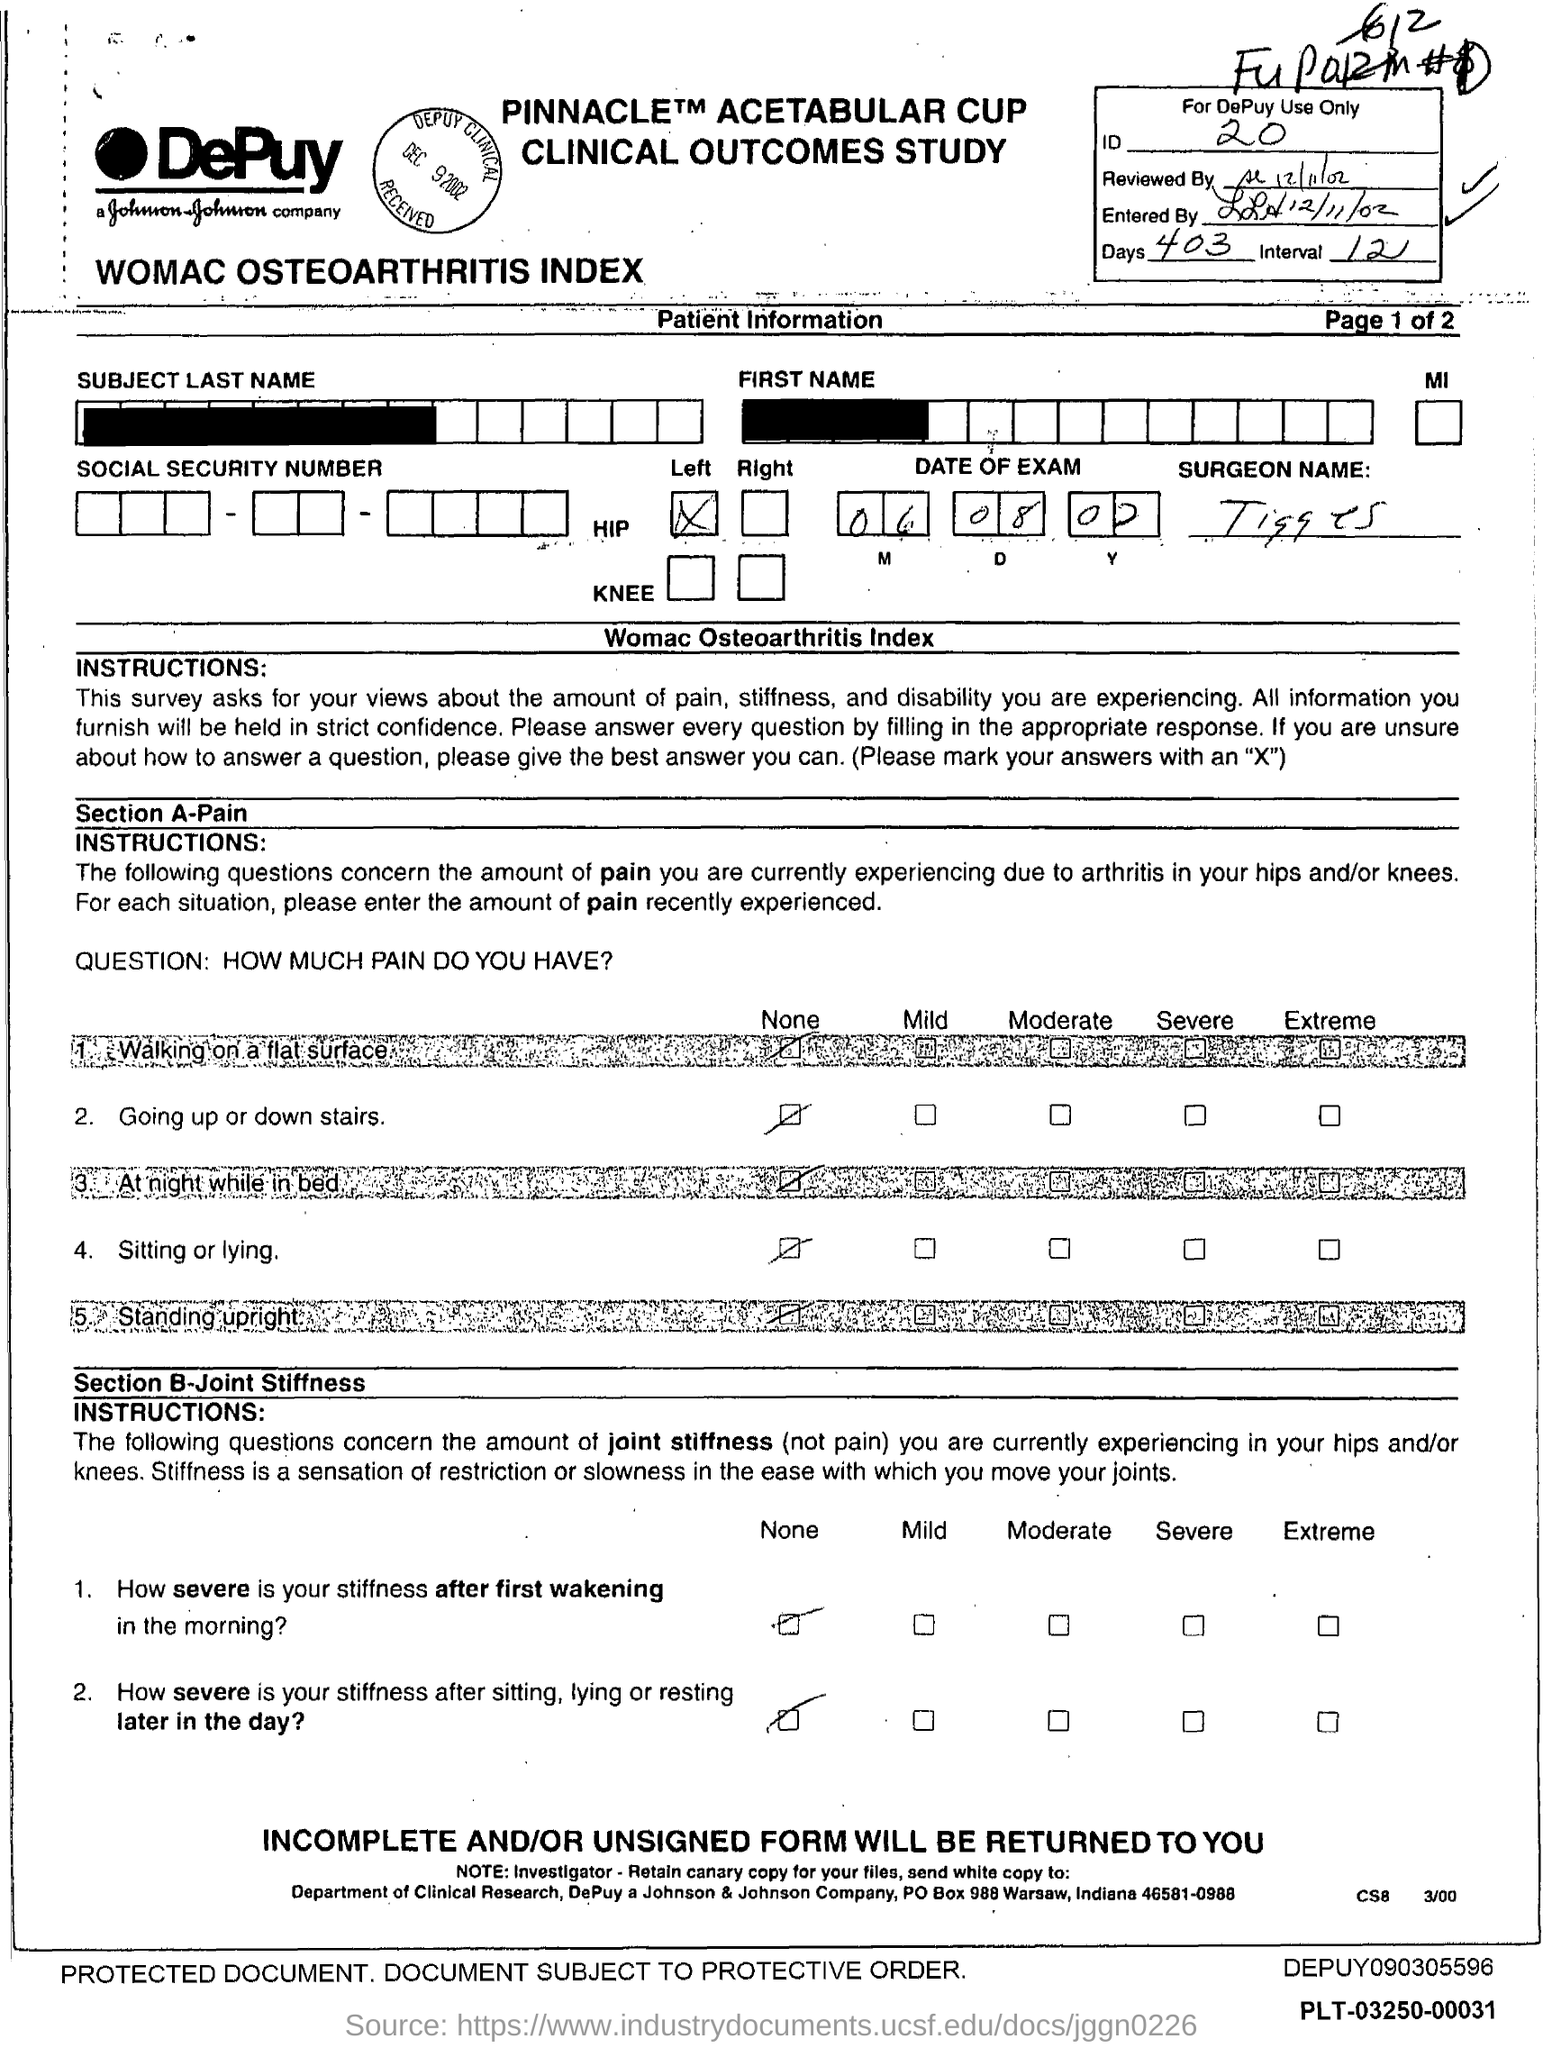What is the ID Number?
Offer a terse response. 20. What is the number of days?
Make the answer very short. 403. What is the number of interval?
Ensure brevity in your answer.  12. 